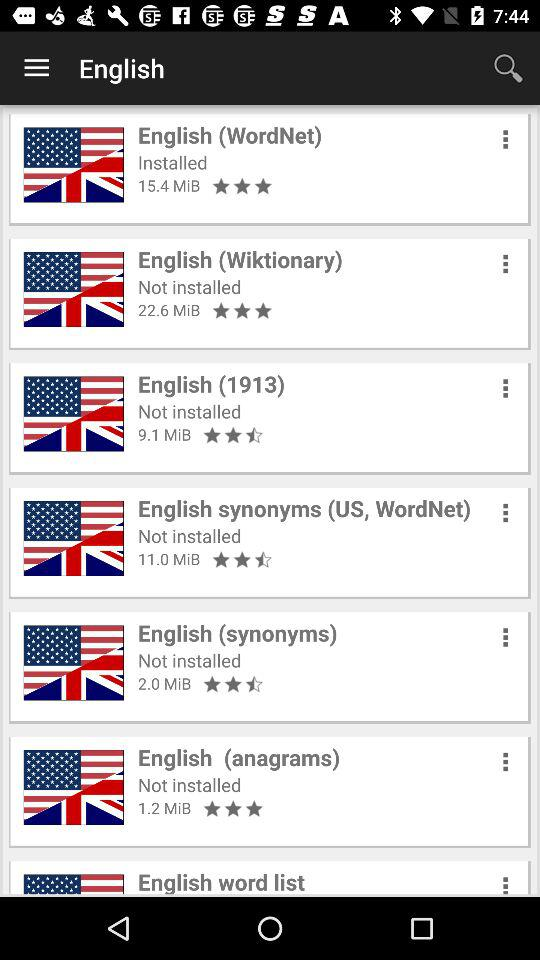What is the rating of the "English synonyms" app? The rating is 2.5 stars. 